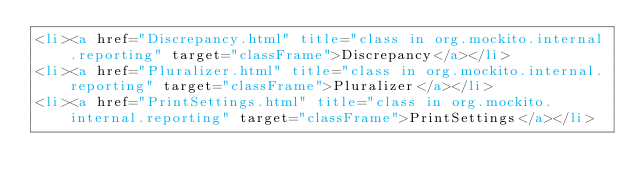<code> <loc_0><loc_0><loc_500><loc_500><_HTML_><li><a href="Discrepancy.html" title="class in org.mockito.internal.reporting" target="classFrame">Discrepancy</a></li>
<li><a href="Pluralizer.html" title="class in org.mockito.internal.reporting" target="classFrame">Pluralizer</a></li>
<li><a href="PrintSettings.html" title="class in org.mockito.internal.reporting" target="classFrame">PrintSettings</a></li></code> 